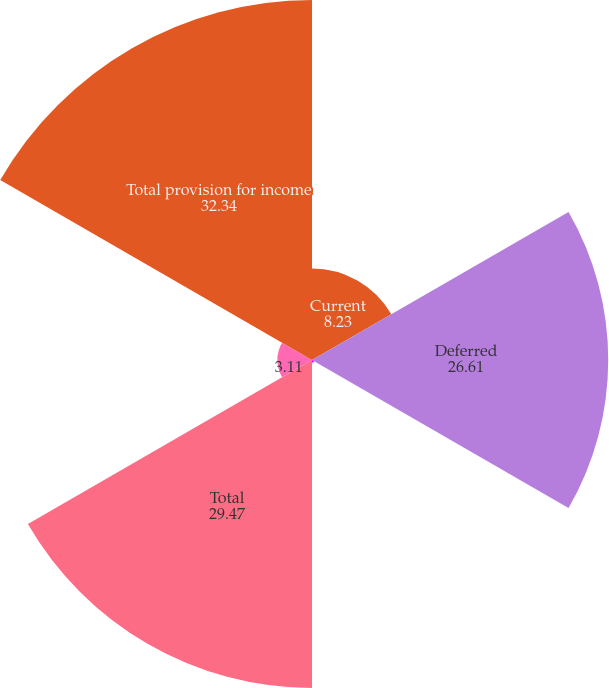<chart> <loc_0><loc_0><loc_500><loc_500><pie_chart><fcel>Current<fcel>Deferred<fcel>State<fcel>Total<fcel>Unnamed: 4<fcel>Total provision for income<nl><fcel>8.23%<fcel>26.61%<fcel>0.24%<fcel>29.47%<fcel>3.11%<fcel>32.34%<nl></chart> 